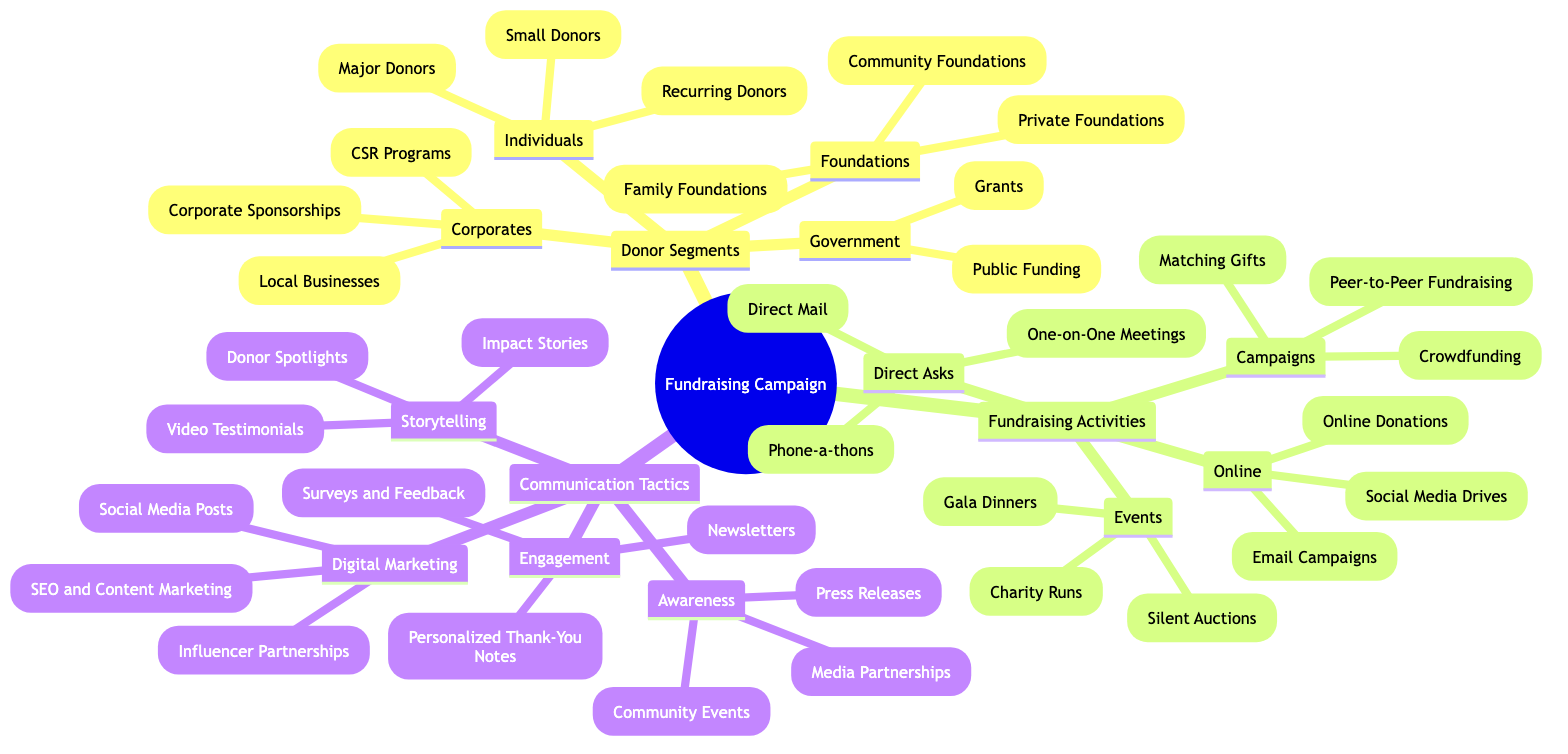What are the segments of donors identified in the campaign? The diagram indicates four main donor segments: Individuals, Corporates, Foundations, and Government, which are categorized horizontally as primary nodes under "Donor Segments."
Answer: Individuals, Corporates, Foundations, Government How many fundraising activities are listed in the diagram? The diagram shows four categories of fundraising activities: Events, Campaigns, Direct Asks, and Online. Counting these categories gives a total of four.
Answer: 4 What fundraising activity is a type of event? Under the "Events" node, examples include Gala Dinners, Charity Runs, and Silent Auctions. Each of these activities falls under the category of events.
Answer: Gala Dinners What types of corporates are mentioned under donor segments? The "Corporates" category lists three types: Local Businesses, Corporate Sponsorships, and CSR Programs. Each type represents a different method of corporate involvement.
Answer: Local Businesses, Corporate Sponsorships, CSR Programs Which communication tactic focuses on storytelling? The "Storytelling" category within "Communication Tactics" specifically highlights Impact Stories, Donor Spotlights, and Video Testimonials. These focus on conveying narratives to engage donors.
Answer: Impact Stories How many types of online fundraising activities are included? The "Online" node lists three activities: Email Campaigns, Social Media Drives, and Online Donations. Counting these activities gives a total of three.
Answer: 3 What is the primary objective of the "Awareness" communication tactic? The "Awareness" category includes strategies such as Press Releases, Media Partnerships, and Community Events. These are primarily intended to raise awareness about the campaign.
Answer: Press Releases What fundraising activity involves direct communication with donors? The "Direct Asks" section highlights activities like One-on-One Meetings, Phone-a-thons, and Direct Mail, which are all forms of direct communication methods.
Answer: One-on-One Meetings Which donor segment includes private foundations? The "Foundations" segment specifically includes Private Foundations among its types listed. This represents a category of donors interested in philanthropic activities.
Answer: Private Foundations 